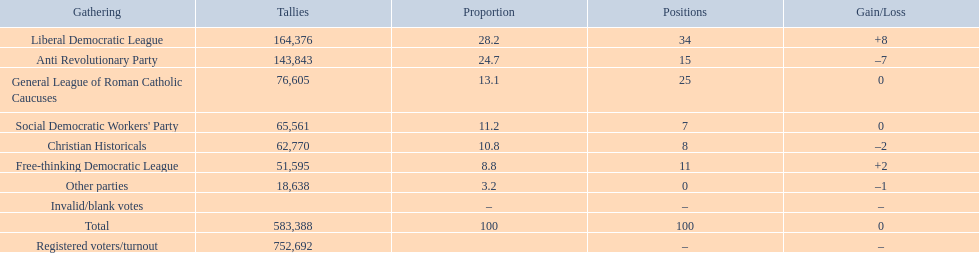How many more votes did the liberal democratic league win over the free-thinking democratic league? 112,781. 